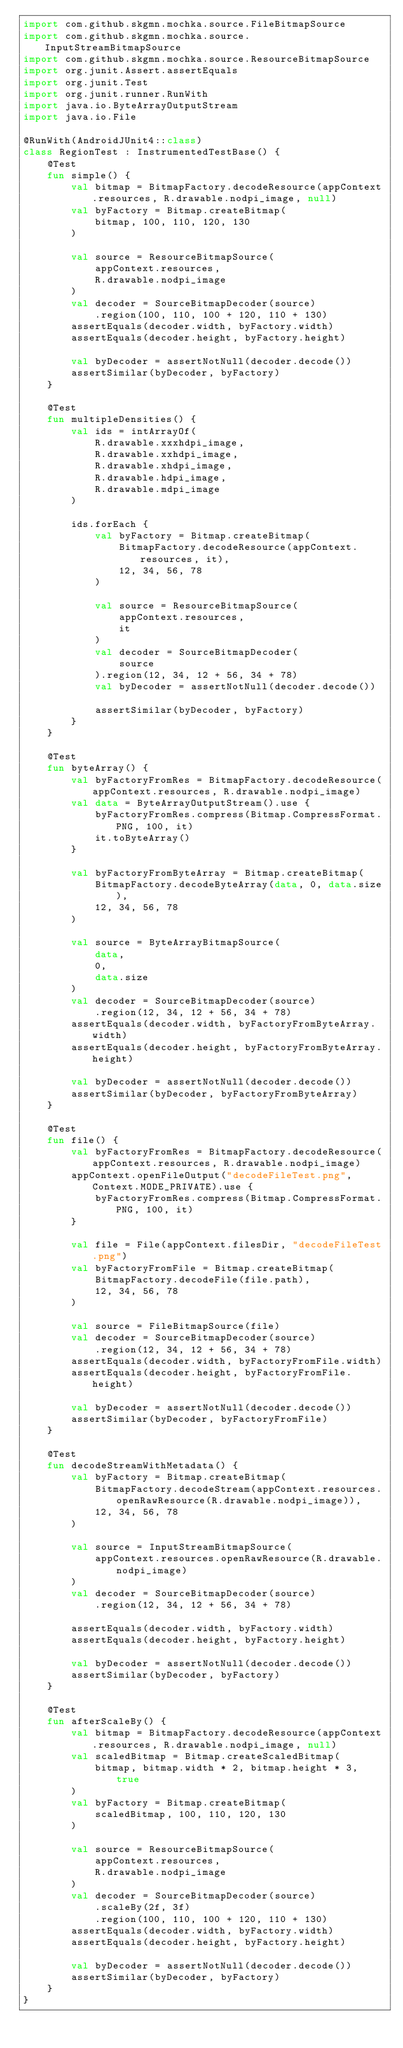Convert code to text. <code><loc_0><loc_0><loc_500><loc_500><_Kotlin_>import com.github.skgmn.mochka.source.FileBitmapSource
import com.github.skgmn.mochka.source.InputStreamBitmapSource
import com.github.skgmn.mochka.source.ResourceBitmapSource
import org.junit.Assert.assertEquals
import org.junit.Test
import org.junit.runner.RunWith
import java.io.ByteArrayOutputStream
import java.io.File

@RunWith(AndroidJUnit4::class)
class RegionTest : InstrumentedTestBase() {
    @Test
    fun simple() {
        val bitmap = BitmapFactory.decodeResource(appContext.resources, R.drawable.nodpi_image, null)
        val byFactory = Bitmap.createBitmap(
            bitmap, 100, 110, 120, 130
        )

        val source = ResourceBitmapSource(
            appContext.resources,
            R.drawable.nodpi_image
        )
        val decoder = SourceBitmapDecoder(source)
            .region(100, 110, 100 + 120, 110 + 130)
        assertEquals(decoder.width, byFactory.width)
        assertEquals(decoder.height, byFactory.height)

        val byDecoder = assertNotNull(decoder.decode())
        assertSimilar(byDecoder, byFactory)
    }

    @Test
    fun multipleDensities() {
        val ids = intArrayOf(
            R.drawable.xxxhdpi_image,
            R.drawable.xxhdpi_image,
            R.drawable.xhdpi_image,
            R.drawable.hdpi_image,
            R.drawable.mdpi_image
        )

        ids.forEach {
            val byFactory = Bitmap.createBitmap(
                BitmapFactory.decodeResource(appContext.resources, it),
                12, 34, 56, 78
            )

            val source = ResourceBitmapSource(
                appContext.resources,
                it
            )
            val decoder = SourceBitmapDecoder(
                source
            ).region(12, 34, 12 + 56, 34 + 78)
            val byDecoder = assertNotNull(decoder.decode())

            assertSimilar(byDecoder, byFactory)
        }
    }

    @Test
    fun byteArray() {
        val byFactoryFromRes = BitmapFactory.decodeResource(appContext.resources, R.drawable.nodpi_image)
        val data = ByteArrayOutputStream().use {
            byFactoryFromRes.compress(Bitmap.CompressFormat.PNG, 100, it)
            it.toByteArray()
        }

        val byFactoryFromByteArray = Bitmap.createBitmap(
            BitmapFactory.decodeByteArray(data, 0, data.size),
            12, 34, 56, 78
        )

        val source = ByteArrayBitmapSource(
            data,
            0,
            data.size
        )
        val decoder = SourceBitmapDecoder(source)
            .region(12, 34, 12 + 56, 34 + 78)
        assertEquals(decoder.width, byFactoryFromByteArray.width)
        assertEquals(decoder.height, byFactoryFromByteArray.height)

        val byDecoder = assertNotNull(decoder.decode())
        assertSimilar(byDecoder, byFactoryFromByteArray)
    }

    @Test
    fun file() {
        val byFactoryFromRes = BitmapFactory.decodeResource(appContext.resources, R.drawable.nodpi_image)
        appContext.openFileOutput("decodeFileTest.png", Context.MODE_PRIVATE).use {
            byFactoryFromRes.compress(Bitmap.CompressFormat.PNG, 100, it)
        }

        val file = File(appContext.filesDir, "decodeFileTest.png")
        val byFactoryFromFile = Bitmap.createBitmap(
            BitmapFactory.decodeFile(file.path),
            12, 34, 56, 78
        )

        val source = FileBitmapSource(file)
        val decoder = SourceBitmapDecoder(source)
            .region(12, 34, 12 + 56, 34 + 78)
        assertEquals(decoder.width, byFactoryFromFile.width)
        assertEquals(decoder.height, byFactoryFromFile.height)

        val byDecoder = assertNotNull(decoder.decode())
        assertSimilar(byDecoder, byFactoryFromFile)
    }

    @Test
    fun decodeStreamWithMetadata() {
        val byFactory = Bitmap.createBitmap(
            BitmapFactory.decodeStream(appContext.resources.openRawResource(R.drawable.nodpi_image)),
            12, 34, 56, 78
        )

        val source = InputStreamBitmapSource(
            appContext.resources.openRawResource(R.drawable.nodpi_image)
        )
        val decoder = SourceBitmapDecoder(source)
            .region(12, 34, 12 + 56, 34 + 78)

        assertEquals(decoder.width, byFactory.width)
        assertEquals(decoder.height, byFactory.height)

        val byDecoder = assertNotNull(decoder.decode())
        assertSimilar(byDecoder, byFactory)
    }

    @Test
    fun afterScaleBy() {
        val bitmap = BitmapFactory.decodeResource(appContext.resources, R.drawable.nodpi_image, null)
        val scaledBitmap = Bitmap.createScaledBitmap(
            bitmap, bitmap.width * 2, bitmap.height * 3, true
        )
        val byFactory = Bitmap.createBitmap(
            scaledBitmap, 100, 110, 120, 130
        )

        val source = ResourceBitmapSource(
            appContext.resources,
            R.drawable.nodpi_image
        )
        val decoder = SourceBitmapDecoder(source)
            .scaleBy(2f, 3f)
            .region(100, 110, 100 + 120, 110 + 130)
        assertEquals(decoder.width, byFactory.width)
        assertEquals(decoder.height, byFactory.height)

        val byDecoder = assertNotNull(decoder.decode())
        assertSimilar(byDecoder, byFactory)
    }
}
</code> 